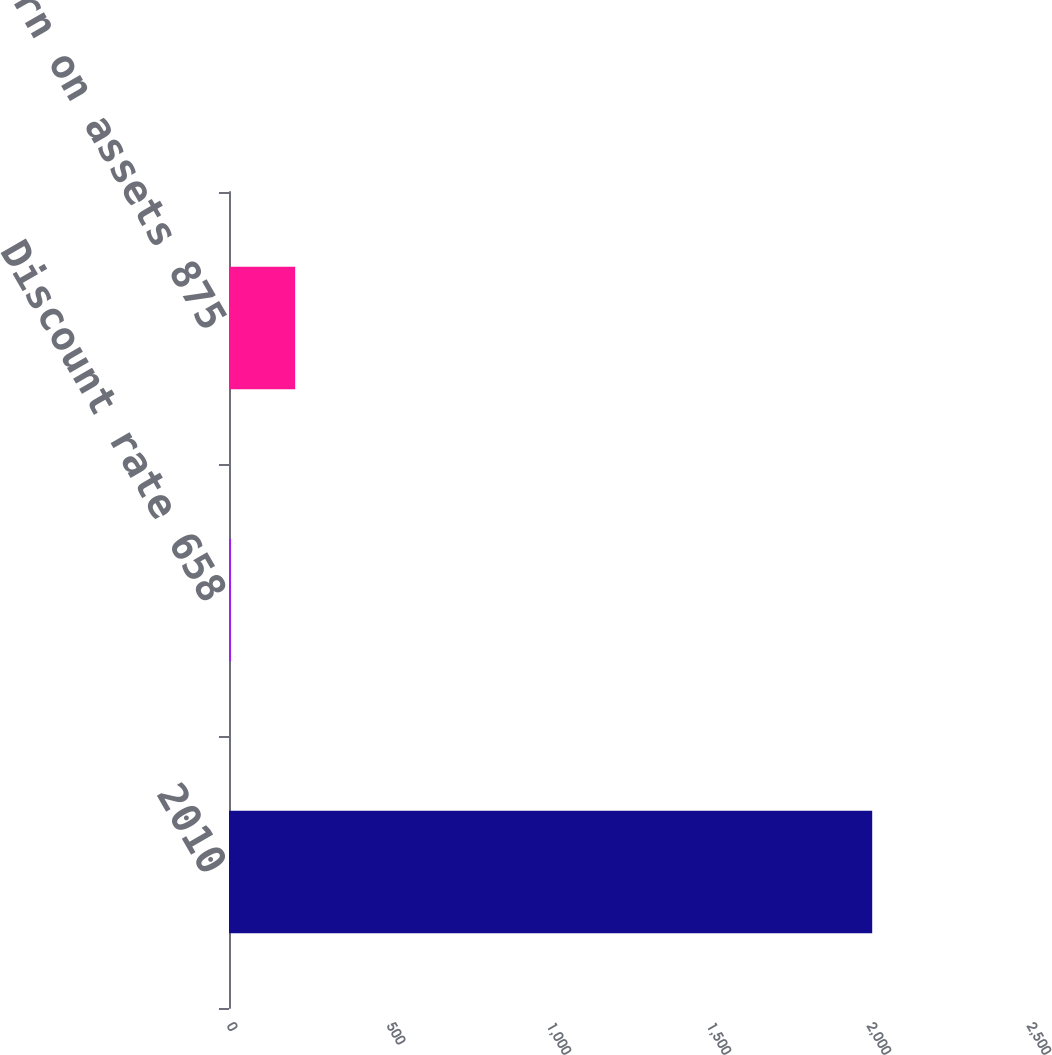<chart> <loc_0><loc_0><loc_500><loc_500><bar_chart><fcel>2010<fcel>Discount rate 658<fcel>Expected return on assets 875<nl><fcel>2010<fcel>6.43<fcel>206.79<nl></chart> 